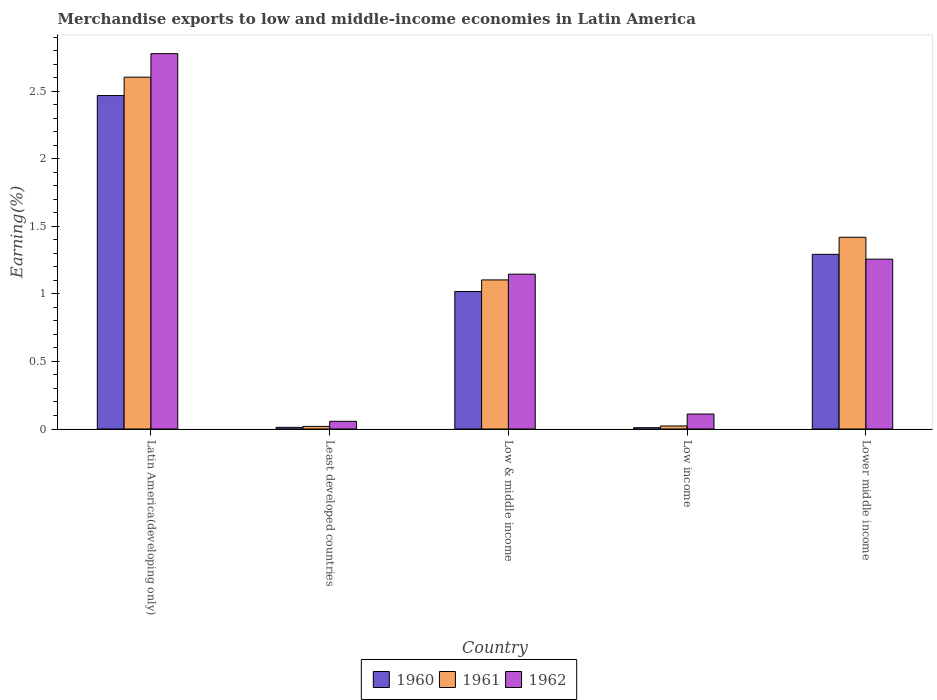How many bars are there on the 4th tick from the left?
Offer a very short reply. 3. What is the percentage of amount earned from merchandise exports in 1961 in Least developed countries?
Make the answer very short. 0.02. Across all countries, what is the maximum percentage of amount earned from merchandise exports in 1961?
Your response must be concise. 2.6. Across all countries, what is the minimum percentage of amount earned from merchandise exports in 1960?
Give a very brief answer. 0.01. In which country was the percentage of amount earned from merchandise exports in 1962 maximum?
Your response must be concise. Latin America(developing only). In which country was the percentage of amount earned from merchandise exports in 1961 minimum?
Give a very brief answer. Least developed countries. What is the total percentage of amount earned from merchandise exports in 1961 in the graph?
Your response must be concise. 5.17. What is the difference between the percentage of amount earned from merchandise exports in 1961 in Latin America(developing only) and that in Low & middle income?
Give a very brief answer. 1.5. What is the difference between the percentage of amount earned from merchandise exports in 1962 in Low income and the percentage of amount earned from merchandise exports in 1960 in Least developed countries?
Offer a terse response. 0.1. What is the average percentage of amount earned from merchandise exports in 1961 per country?
Keep it short and to the point. 1.03. What is the difference between the percentage of amount earned from merchandise exports of/in 1961 and percentage of amount earned from merchandise exports of/in 1962 in Lower middle income?
Make the answer very short. 0.16. What is the ratio of the percentage of amount earned from merchandise exports in 1961 in Low & middle income to that in Lower middle income?
Ensure brevity in your answer.  0.78. Is the percentage of amount earned from merchandise exports in 1961 in Least developed countries less than that in Low & middle income?
Keep it short and to the point. Yes. Is the difference between the percentage of amount earned from merchandise exports in 1961 in Low & middle income and Lower middle income greater than the difference between the percentage of amount earned from merchandise exports in 1962 in Low & middle income and Lower middle income?
Your answer should be compact. No. What is the difference between the highest and the second highest percentage of amount earned from merchandise exports in 1962?
Make the answer very short. -1.52. What is the difference between the highest and the lowest percentage of amount earned from merchandise exports in 1961?
Provide a short and direct response. 2.58. In how many countries, is the percentage of amount earned from merchandise exports in 1962 greater than the average percentage of amount earned from merchandise exports in 1962 taken over all countries?
Ensure brevity in your answer.  3. Is the sum of the percentage of amount earned from merchandise exports in 1961 in Latin America(developing only) and Least developed countries greater than the maximum percentage of amount earned from merchandise exports in 1960 across all countries?
Your response must be concise. Yes. How many bars are there?
Offer a very short reply. 15. Are all the bars in the graph horizontal?
Your answer should be compact. No. How many countries are there in the graph?
Your response must be concise. 5. Does the graph contain any zero values?
Provide a succinct answer. No. How many legend labels are there?
Offer a very short reply. 3. How are the legend labels stacked?
Give a very brief answer. Horizontal. What is the title of the graph?
Provide a succinct answer. Merchandise exports to low and middle-income economies in Latin America. What is the label or title of the X-axis?
Provide a succinct answer. Country. What is the label or title of the Y-axis?
Make the answer very short. Earning(%). What is the Earning(%) in 1960 in Latin America(developing only)?
Your answer should be compact. 2.47. What is the Earning(%) in 1961 in Latin America(developing only)?
Make the answer very short. 2.6. What is the Earning(%) of 1962 in Latin America(developing only)?
Keep it short and to the point. 2.78. What is the Earning(%) in 1960 in Least developed countries?
Give a very brief answer. 0.01. What is the Earning(%) of 1961 in Least developed countries?
Make the answer very short. 0.02. What is the Earning(%) in 1962 in Least developed countries?
Give a very brief answer. 0.06. What is the Earning(%) in 1960 in Low & middle income?
Offer a terse response. 1.02. What is the Earning(%) of 1961 in Low & middle income?
Your answer should be compact. 1.1. What is the Earning(%) in 1962 in Low & middle income?
Your answer should be compact. 1.15. What is the Earning(%) in 1960 in Low income?
Provide a succinct answer. 0.01. What is the Earning(%) in 1961 in Low income?
Keep it short and to the point. 0.02. What is the Earning(%) of 1962 in Low income?
Give a very brief answer. 0.11. What is the Earning(%) in 1960 in Lower middle income?
Keep it short and to the point. 1.29. What is the Earning(%) in 1961 in Lower middle income?
Provide a succinct answer. 1.42. What is the Earning(%) of 1962 in Lower middle income?
Keep it short and to the point. 1.26. Across all countries, what is the maximum Earning(%) of 1960?
Ensure brevity in your answer.  2.47. Across all countries, what is the maximum Earning(%) of 1961?
Ensure brevity in your answer.  2.6. Across all countries, what is the maximum Earning(%) of 1962?
Offer a terse response. 2.78. Across all countries, what is the minimum Earning(%) of 1960?
Give a very brief answer. 0.01. Across all countries, what is the minimum Earning(%) in 1961?
Offer a very short reply. 0.02. Across all countries, what is the minimum Earning(%) of 1962?
Give a very brief answer. 0.06. What is the total Earning(%) of 1960 in the graph?
Provide a short and direct response. 4.8. What is the total Earning(%) in 1961 in the graph?
Your answer should be very brief. 5.17. What is the total Earning(%) in 1962 in the graph?
Your answer should be very brief. 5.35. What is the difference between the Earning(%) of 1960 in Latin America(developing only) and that in Least developed countries?
Offer a terse response. 2.46. What is the difference between the Earning(%) of 1961 in Latin America(developing only) and that in Least developed countries?
Your answer should be compact. 2.58. What is the difference between the Earning(%) of 1962 in Latin America(developing only) and that in Least developed countries?
Offer a terse response. 2.72. What is the difference between the Earning(%) of 1960 in Latin America(developing only) and that in Low & middle income?
Give a very brief answer. 1.45. What is the difference between the Earning(%) of 1961 in Latin America(developing only) and that in Low & middle income?
Your answer should be compact. 1.5. What is the difference between the Earning(%) in 1962 in Latin America(developing only) and that in Low & middle income?
Offer a terse response. 1.63. What is the difference between the Earning(%) in 1960 in Latin America(developing only) and that in Low income?
Keep it short and to the point. 2.46. What is the difference between the Earning(%) in 1961 in Latin America(developing only) and that in Low income?
Make the answer very short. 2.58. What is the difference between the Earning(%) in 1962 in Latin America(developing only) and that in Low income?
Make the answer very short. 2.67. What is the difference between the Earning(%) of 1960 in Latin America(developing only) and that in Lower middle income?
Your response must be concise. 1.18. What is the difference between the Earning(%) in 1961 in Latin America(developing only) and that in Lower middle income?
Provide a succinct answer. 1.19. What is the difference between the Earning(%) in 1962 in Latin America(developing only) and that in Lower middle income?
Your answer should be compact. 1.52. What is the difference between the Earning(%) in 1960 in Least developed countries and that in Low & middle income?
Provide a succinct answer. -1.01. What is the difference between the Earning(%) in 1961 in Least developed countries and that in Low & middle income?
Your answer should be compact. -1.08. What is the difference between the Earning(%) in 1962 in Least developed countries and that in Low & middle income?
Provide a succinct answer. -1.09. What is the difference between the Earning(%) in 1960 in Least developed countries and that in Low income?
Provide a succinct answer. 0. What is the difference between the Earning(%) of 1961 in Least developed countries and that in Low income?
Offer a very short reply. -0. What is the difference between the Earning(%) in 1962 in Least developed countries and that in Low income?
Provide a short and direct response. -0.05. What is the difference between the Earning(%) in 1960 in Least developed countries and that in Lower middle income?
Provide a short and direct response. -1.28. What is the difference between the Earning(%) in 1961 in Least developed countries and that in Lower middle income?
Your answer should be compact. -1.4. What is the difference between the Earning(%) of 1962 in Least developed countries and that in Lower middle income?
Your response must be concise. -1.2. What is the difference between the Earning(%) of 1960 in Low & middle income and that in Low income?
Keep it short and to the point. 1.01. What is the difference between the Earning(%) of 1961 in Low & middle income and that in Low income?
Make the answer very short. 1.08. What is the difference between the Earning(%) of 1962 in Low & middle income and that in Low income?
Make the answer very short. 1.03. What is the difference between the Earning(%) in 1960 in Low & middle income and that in Lower middle income?
Make the answer very short. -0.27. What is the difference between the Earning(%) of 1961 in Low & middle income and that in Lower middle income?
Your response must be concise. -0.32. What is the difference between the Earning(%) in 1962 in Low & middle income and that in Lower middle income?
Provide a succinct answer. -0.11. What is the difference between the Earning(%) in 1960 in Low income and that in Lower middle income?
Your answer should be very brief. -1.28. What is the difference between the Earning(%) in 1961 in Low income and that in Lower middle income?
Ensure brevity in your answer.  -1.4. What is the difference between the Earning(%) in 1962 in Low income and that in Lower middle income?
Your answer should be compact. -1.15. What is the difference between the Earning(%) of 1960 in Latin America(developing only) and the Earning(%) of 1961 in Least developed countries?
Give a very brief answer. 2.45. What is the difference between the Earning(%) in 1960 in Latin America(developing only) and the Earning(%) in 1962 in Least developed countries?
Provide a short and direct response. 2.41. What is the difference between the Earning(%) in 1961 in Latin America(developing only) and the Earning(%) in 1962 in Least developed countries?
Provide a short and direct response. 2.55. What is the difference between the Earning(%) of 1960 in Latin America(developing only) and the Earning(%) of 1961 in Low & middle income?
Your answer should be very brief. 1.36. What is the difference between the Earning(%) of 1960 in Latin America(developing only) and the Earning(%) of 1962 in Low & middle income?
Your answer should be very brief. 1.32. What is the difference between the Earning(%) in 1961 in Latin America(developing only) and the Earning(%) in 1962 in Low & middle income?
Give a very brief answer. 1.46. What is the difference between the Earning(%) in 1960 in Latin America(developing only) and the Earning(%) in 1961 in Low income?
Ensure brevity in your answer.  2.45. What is the difference between the Earning(%) of 1960 in Latin America(developing only) and the Earning(%) of 1962 in Low income?
Your answer should be very brief. 2.36. What is the difference between the Earning(%) in 1961 in Latin America(developing only) and the Earning(%) in 1962 in Low income?
Offer a terse response. 2.49. What is the difference between the Earning(%) in 1960 in Latin America(developing only) and the Earning(%) in 1961 in Lower middle income?
Make the answer very short. 1.05. What is the difference between the Earning(%) of 1960 in Latin America(developing only) and the Earning(%) of 1962 in Lower middle income?
Keep it short and to the point. 1.21. What is the difference between the Earning(%) of 1961 in Latin America(developing only) and the Earning(%) of 1962 in Lower middle income?
Ensure brevity in your answer.  1.35. What is the difference between the Earning(%) of 1960 in Least developed countries and the Earning(%) of 1961 in Low & middle income?
Your answer should be compact. -1.09. What is the difference between the Earning(%) in 1960 in Least developed countries and the Earning(%) in 1962 in Low & middle income?
Offer a very short reply. -1.13. What is the difference between the Earning(%) of 1961 in Least developed countries and the Earning(%) of 1962 in Low & middle income?
Make the answer very short. -1.13. What is the difference between the Earning(%) in 1960 in Least developed countries and the Earning(%) in 1961 in Low income?
Offer a terse response. -0.01. What is the difference between the Earning(%) in 1960 in Least developed countries and the Earning(%) in 1962 in Low income?
Keep it short and to the point. -0.1. What is the difference between the Earning(%) in 1961 in Least developed countries and the Earning(%) in 1962 in Low income?
Provide a succinct answer. -0.09. What is the difference between the Earning(%) in 1960 in Least developed countries and the Earning(%) in 1961 in Lower middle income?
Provide a succinct answer. -1.41. What is the difference between the Earning(%) in 1960 in Least developed countries and the Earning(%) in 1962 in Lower middle income?
Offer a terse response. -1.25. What is the difference between the Earning(%) of 1961 in Least developed countries and the Earning(%) of 1962 in Lower middle income?
Give a very brief answer. -1.24. What is the difference between the Earning(%) in 1960 in Low & middle income and the Earning(%) in 1962 in Low income?
Offer a terse response. 0.91. What is the difference between the Earning(%) in 1960 in Low & middle income and the Earning(%) in 1961 in Lower middle income?
Provide a short and direct response. -0.4. What is the difference between the Earning(%) of 1960 in Low & middle income and the Earning(%) of 1962 in Lower middle income?
Your answer should be very brief. -0.24. What is the difference between the Earning(%) of 1961 in Low & middle income and the Earning(%) of 1962 in Lower middle income?
Provide a short and direct response. -0.15. What is the difference between the Earning(%) of 1960 in Low income and the Earning(%) of 1961 in Lower middle income?
Offer a very short reply. -1.41. What is the difference between the Earning(%) in 1960 in Low income and the Earning(%) in 1962 in Lower middle income?
Make the answer very short. -1.25. What is the difference between the Earning(%) in 1961 in Low income and the Earning(%) in 1962 in Lower middle income?
Provide a short and direct response. -1.23. What is the average Earning(%) of 1960 per country?
Offer a very short reply. 0.96. What is the average Earning(%) of 1961 per country?
Give a very brief answer. 1.03. What is the average Earning(%) in 1962 per country?
Your response must be concise. 1.07. What is the difference between the Earning(%) of 1960 and Earning(%) of 1961 in Latin America(developing only)?
Ensure brevity in your answer.  -0.14. What is the difference between the Earning(%) of 1960 and Earning(%) of 1962 in Latin America(developing only)?
Give a very brief answer. -0.31. What is the difference between the Earning(%) of 1961 and Earning(%) of 1962 in Latin America(developing only)?
Give a very brief answer. -0.17. What is the difference between the Earning(%) of 1960 and Earning(%) of 1961 in Least developed countries?
Ensure brevity in your answer.  -0.01. What is the difference between the Earning(%) in 1960 and Earning(%) in 1962 in Least developed countries?
Your answer should be very brief. -0.04. What is the difference between the Earning(%) of 1961 and Earning(%) of 1962 in Least developed countries?
Provide a succinct answer. -0.04. What is the difference between the Earning(%) of 1960 and Earning(%) of 1961 in Low & middle income?
Keep it short and to the point. -0.09. What is the difference between the Earning(%) in 1960 and Earning(%) in 1962 in Low & middle income?
Your answer should be compact. -0.13. What is the difference between the Earning(%) in 1961 and Earning(%) in 1962 in Low & middle income?
Your answer should be compact. -0.04. What is the difference between the Earning(%) of 1960 and Earning(%) of 1961 in Low income?
Provide a short and direct response. -0.01. What is the difference between the Earning(%) in 1960 and Earning(%) in 1962 in Low income?
Give a very brief answer. -0.1. What is the difference between the Earning(%) in 1961 and Earning(%) in 1962 in Low income?
Ensure brevity in your answer.  -0.09. What is the difference between the Earning(%) in 1960 and Earning(%) in 1961 in Lower middle income?
Your answer should be very brief. -0.13. What is the difference between the Earning(%) of 1960 and Earning(%) of 1962 in Lower middle income?
Provide a short and direct response. 0.04. What is the difference between the Earning(%) in 1961 and Earning(%) in 1962 in Lower middle income?
Ensure brevity in your answer.  0.16. What is the ratio of the Earning(%) of 1960 in Latin America(developing only) to that in Least developed countries?
Provide a short and direct response. 199.93. What is the ratio of the Earning(%) in 1961 in Latin America(developing only) to that in Least developed countries?
Offer a very short reply. 133.49. What is the ratio of the Earning(%) of 1962 in Latin America(developing only) to that in Least developed countries?
Your response must be concise. 48.79. What is the ratio of the Earning(%) of 1960 in Latin America(developing only) to that in Low & middle income?
Offer a terse response. 2.42. What is the ratio of the Earning(%) of 1961 in Latin America(developing only) to that in Low & middle income?
Offer a terse response. 2.36. What is the ratio of the Earning(%) of 1962 in Latin America(developing only) to that in Low & middle income?
Offer a terse response. 2.42. What is the ratio of the Earning(%) in 1960 in Latin America(developing only) to that in Low income?
Keep it short and to the point. 251.73. What is the ratio of the Earning(%) of 1961 in Latin America(developing only) to that in Low income?
Ensure brevity in your answer.  115.27. What is the ratio of the Earning(%) in 1962 in Latin America(developing only) to that in Low income?
Keep it short and to the point. 25.04. What is the ratio of the Earning(%) in 1960 in Latin America(developing only) to that in Lower middle income?
Your answer should be very brief. 1.91. What is the ratio of the Earning(%) in 1961 in Latin America(developing only) to that in Lower middle income?
Provide a short and direct response. 1.84. What is the ratio of the Earning(%) of 1962 in Latin America(developing only) to that in Lower middle income?
Ensure brevity in your answer.  2.21. What is the ratio of the Earning(%) in 1960 in Least developed countries to that in Low & middle income?
Provide a succinct answer. 0.01. What is the ratio of the Earning(%) in 1961 in Least developed countries to that in Low & middle income?
Give a very brief answer. 0.02. What is the ratio of the Earning(%) in 1962 in Least developed countries to that in Low & middle income?
Offer a terse response. 0.05. What is the ratio of the Earning(%) of 1960 in Least developed countries to that in Low income?
Provide a succinct answer. 1.26. What is the ratio of the Earning(%) in 1961 in Least developed countries to that in Low income?
Offer a very short reply. 0.86. What is the ratio of the Earning(%) in 1962 in Least developed countries to that in Low income?
Your answer should be compact. 0.51. What is the ratio of the Earning(%) in 1960 in Least developed countries to that in Lower middle income?
Provide a succinct answer. 0.01. What is the ratio of the Earning(%) of 1961 in Least developed countries to that in Lower middle income?
Make the answer very short. 0.01. What is the ratio of the Earning(%) in 1962 in Least developed countries to that in Lower middle income?
Offer a terse response. 0.05. What is the ratio of the Earning(%) in 1960 in Low & middle income to that in Low income?
Offer a terse response. 103.82. What is the ratio of the Earning(%) of 1961 in Low & middle income to that in Low income?
Your answer should be compact. 48.85. What is the ratio of the Earning(%) of 1962 in Low & middle income to that in Low income?
Provide a short and direct response. 10.33. What is the ratio of the Earning(%) of 1960 in Low & middle income to that in Lower middle income?
Give a very brief answer. 0.79. What is the ratio of the Earning(%) in 1961 in Low & middle income to that in Lower middle income?
Offer a terse response. 0.78. What is the ratio of the Earning(%) of 1962 in Low & middle income to that in Lower middle income?
Provide a short and direct response. 0.91. What is the ratio of the Earning(%) in 1960 in Low income to that in Lower middle income?
Your answer should be compact. 0.01. What is the ratio of the Earning(%) of 1961 in Low income to that in Lower middle income?
Provide a short and direct response. 0.02. What is the ratio of the Earning(%) in 1962 in Low income to that in Lower middle income?
Provide a short and direct response. 0.09. What is the difference between the highest and the second highest Earning(%) of 1960?
Ensure brevity in your answer.  1.18. What is the difference between the highest and the second highest Earning(%) of 1961?
Ensure brevity in your answer.  1.19. What is the difference between the highest and the second highest Earning(%) of 1962?
Your response must be concise. 1.52. What is the difference between the highest and the lowest Earning(%) of 1960?
Provide a succinct answer. 2.46. What is the difference between the highest and the lowest Earning(%) of 1961?
Ensure brevity in your answer.  2.58. What is the difference between the highest and the lowest Earning(%) of 1962?
Ensure brevity in your answer.  2.72. 